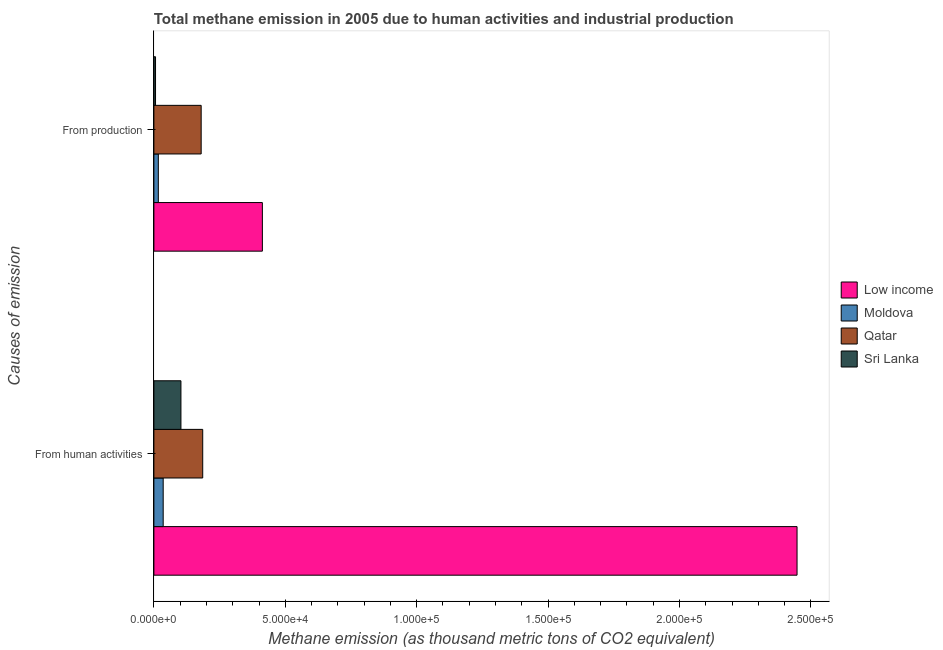Are the number of bars per tick equal to the number of legend labels?
Make the answer very short. Yes. What is the label of the 2nd group of bars from the top?
Your response must be concise. From human activities. What is the amount of emissions generated from industries in Sri Lanka?
Your response must be concise. 627.3. Across all countries, what is the maximum amount of emissions from human activities?
Provide a short and direct response. 2.45e+05. Across all countries, what is the minimum amount of emissions generated from industries?
Offer a terse response. 627.3. In which country was the amount of emissions generated from industries maximum?
Your response must be concise. Low income. In which country was the amount of emissions from human activities minimum?
Provide a succinct answer. Moldova. What is the total amount of emissions from human activities in the graph?
Your response must be concise. 2.77e+05. What is the difference between the amount of emissions from human activities in Qatar and that in Low income?
Your answer should be compact. -2.26e+05. What is the difference between the amount of emissions generated from industries in Sri Lanka and the amount of emissions from human activities in Low income?
Make the answer very short. -2.44e+05. What is the average amount of emissions from human activities per country?
Ensure brevity in your answer.  6.93e+04. What is the difference between the amount of emissions generated from industries and amount of emissions from human activities in Moldova?
Provide a succinct answer. -1849.5. What is the ratio of the amount of emissions generated from industries in Low income to that in Qatar?
Give a very brief answer. 2.29. What does the 3rd bar from the bottom in From human activities represents?
Your answer should be very brief. Qatar. How many bars are there?
Your answer should be compact. 8. Are the values on the major ticks of X-axis written in scientific E-notation?
Make the answer very short. Yes. Does the graph contain any zero values?
Keep it short and to the point. No. Where does the legend appear in the graph?
Give a very brief answer. Center right. What is the title of the graph?
Provide a succinct answer. Total methane emission in 2005 due to human activities and industrial production. Does "United Arab Emirates" appear as one of the legend labels in the graph?
Provide a succinct answer. No. What is the label or title of the X-axis?
Your answer should be very brief. Methane emission (as thousand metric tons of CO2 equivalent). What is the label or title of the Y-axis?
Keep it short and to the point. Causes of emission. What is the Methane emission (as thousand metric tons of CO2 equivalent) of Low income in From human activities?
Your answer should be compact. 2.45e+05. What is the Methane emission (as thousand metric tons of CO2 equivalent) of Moldova in From human activities?
Offer a terse response. 3540.6. What is the Methane emission (as thousand metric tons of CO2 equivalent) in Qatar in From human activities?
Provide a succinct answer. 1.86e+04. What is the Methane emission (as thousand metric tons of CO2 equivalent) of Sri Lanka in From human activities?
Your answer should be compact. 1.03e+04. What is the Methane emission (as thousand metric tons of CO2 equivalent) of Low income in From production?
Provide a short and direct response. 4.13e+04. What is the Methane emission (as thousand metric tons of CO2 equivalent) of Moldova in From production?
Offer a very short reply. 1691.1. What is the Methane emission (as thousand metric tons of CO2 equivalent) in Qatar in From production?
Your answer should be compact. 1.80e+04. What is the Methane emission (as thousand metric tons of CO2 equivalent) of Sri Lanka in From production?
Give a very brief answer. 627.3. Across all Causes of emission, what is the maximum Methane emission (as thousand metric tons of CO2 equivalent) in Low income?
Provide a short and direct response. 2.45e+05. Across all Causes of emission, what is the maximum Methane emission (as thousand metric tons of CO2 equivalent) in Moldova?
Offer a very short reply. 3540.6. Across all Causes of emission, what is the maximum Methane emission (as thousand metric tons of CO2 equivalent) of Qatar?
Offer a terse response. 1.86e+04. Across all Causes of emission, what is the maximum Methane emission (as thousand metric tons of CO2 equivalent) in Sri Lanka?
Offer a very short reply. 1.03e+04. Across all Causes of emission, what is the minimum Methane emission (as thousand metric tons of CO2 equivalent) in Low income?
Offer a terse response. 4.13e+04. Across all Causes of emission, what is the minimum Methane emission (as thousand metric tons of CO2 equivalent) in Moldova?
Keep it short and to the point. 1691.1. Across all Causes of emission, what is the minimum Methane emission (as thousand metric tons of CO2 equivalent) in Qatar?
Make the answer very short. 1.80e+04. Across all Causes of emission, what is the minimum Methane emission (as thousand metric tons of CO2 equivalent) of Sri Lanka?
Offer a terse response. 627.3. What is the total Methane emission (as thousand metric tons of CO2 equivalent) of Low income in the graph?
Keep it short and to the point. 2.86e+05. What is the total Methane emission (as thousand metric tons of CO2 equivalent) of Moldova in the graph?
Your answer should be compact. 5231.7. What is the total Methane emission (as thousand metric tons of CO2 equivalent) in Qatar in the graph?
Provide a succinct answer. 3.66e+04. What is the total Methane emission (as thousand metric tons of CO2 equivalent) in Sri Lanka in the graph?
Your response must be concise. 1.09e+04. What is the difference between the Methane emission (as thousand metric tons of CO2 equivalent) of Low income in From human activities and that in From production?
Give a very brief answer. 2.03e+05. What is the difference between the Methane emission (as thousand metric tons of CO2 equivalent) of Moldova in From human activities and that in From production?
Ensure brevity in your answer.  1849.5. What is the difference between the Methane emission (as thousand metric tons of CO2 equivalent) in Qatar in From human activities and that in From production?
Provide a short and direct response. 589.5. What is the difference between the Methane emission (as thousand metric tons of CO2 equivalent) in Sri Lanka in From human activities and that in From production?
Provide a short and direct response. 9667.2. What is the difference between the Methane emission (as thousand metric tons of CO2 equivalent) in Low income in From human activities and the Methane emission (as thousand metric tons of CO2 equivalent) in Moldova in From production?
Offer a very short reply. 2.43e+05. What is the difference between the Methane emission (as thousand metric tons of CO2 equivalent) in Low income in From human activities and the Methane emission (as thousand metric tons of CO2 equivalent) in Qatar in From production?
Your answer should be very brief. 2.27e+05. What is the difference between the Methane emission (as thousand metric tons of CO2 equivalent) in Low income in From human activities and the Methane emission (as thousand metric tons of CO2 equivalent) in Sri Lanka in From production?
Your answer should be very brief. 2.44e+05. What is the difference between the Methane emission (as thousand metric tons of CO2 equivalent) of Moldova in From human activities and the Methane emission (as thousand metric tons of CO2 equivalent) of Qatar in From production?
Your answer should be compact. -1.45e+04. What is the difference between the Methane emission (as thousand metric tons of CO2 equivalent) of Moldova in From human activities and the Methane emission (as thousand metric tons of CO2 equivalent) of Sri Lanka in From production?
Ensure brevity in your answer.  2913.3. What is the difference between the Methane emission (as thousand metric tons of CO2 equivalent) in Qatar in From human activities and the Methane emission (as thousand metric tons of CO2 equivalent) in Sri Lanka in From production?
Your response must be concise. 1.80e+04. What is the average Methane emission (as thousand metric tons of CO2 equivalent) in Low income per Causes of emission?
Offer a terse response. 1.43e+05. What is the average Methane emission (as thousand metric tons of CO2 equivalent) in Moldova per Causes of emission?
Ensure brevity in your answer.  2615.85. What is the average Methane emission (as thousand metric tons of CO2 equivalent) in Qatar per Causes of emission?
Your answer should be very brief. 1.83e+04. What is the average Methane emission (as thousand metric tons of CO2 equivalent) in Sri Lanka per Causes of emission?
Your answer should be very brief. 5460.9. What is the difference between the Methane emission (as thousand metric tons of CO2 equivalent) of Low income and Methane emission (as thousand metric tons of CO2 equivalent) of Moldova in From human activities?
Your response must be concise. 2.41e+05. What is the difference between the Methane emission (as thousand metric tons of CO2 equivalent) of Low income and Methane emission (as thousand metric tons of CO2 equivalent) of Qatar in From human activities?
Provide a short and direct response. 2.26e+05. What is the difference between the Methane emission (as thousand metric tons of CO2 equivalent) in Low income and Methane emission (as thousand metric tons of CO2 equivalent) in Sri Lanka in From human activities?
Your answer should be compact. 2.34e+05. What is the difference between the Methane emission (as thousand metric tons of CO2 equivalent) of Moldova and Methane emission (as thousand metric tons of CO2 equivalent) of Qatar in From human activities?
Give a very brief answer. -1.50e+04. What is the difference between the Methane emission (as thousand metric tons of CO2 equivalent) of Moldova and Methane emission (as thousand metric tons of CO2 equivalent) of Sri Lanka in From human activities?
Your response must be concise. -6753.9. What is the difference between the Methane emission (as thousand metric tons of CO2 equivalent) of Qatar and Methane emission (as thousand metric tons of CO2 equivalent) of Sri Lanka in From human activities?
Provide a short and direct response. 8286.2. What is the difference between the Methane emission (as thousand metric tons of CO2 equivalent) in Low income and Methane emission (as thousand metric tons of CO2 equivalent) in Moldova in From production?
Make the answer very short. 3.96e+04. What is the difference between the Methane emission (as thousand metric tons of CO2 equivalent) in Low income and Methane emission (as thousand metric tons of CO2 equivalent) in Qatar in From production?
Your answer should be compact. 2.33e+04. What is the difference between the Methane emission (as thousand metric tons of CO2 equivalent) of Low income and Methane emission (as thousand metric tons of CO2 equivalent) of Sri Lanka in From production?
Offer a very short reply. 4.07e+04. What is the difference between the Methane emission (as thousand metric tons of CO2 equivalent) of Moldova and Methane emission (as thousand metric tons of CO2 equivalent) of Qatar in From production?
Your answer should be very brief. -1.63e+04. What is the difference between the Methane emission (as thousand metric tons of CO2 equivalent) in Moldova and Methane emission (as thousand metric tons of CO2 equivalent) in Sri Lanka in From production?
Provide a succinct answer. 1063.8. What is the difference between the Methane emission (as thousand metric tons of CO2 equivalent) in Qatar and Methane emission (as thousand metric tons of CO2 equivalent) in Sri Lanka in From production?
Your response must be concise. 1.74e+04. What is the ratio of the Methane emission (as thousand metric tons of CO2 equivalent) of Low income in From human activities to that in From production?
Offer a terse response. 5.93. What is the ratio of the Methane emission (as thousand metric tons of CO2 equivalent) in Moldova in From human activities to that in From production?
Ensure brevity in your answer.  2.09. What is the ratio of the Methane emission (as thousand metric tons of CO2 equivalent) in Qatar in From human activities to that in From production?
Your response must be concise. 1.03. What is the ratio of the Methane emission (as thousand metric tons of CO2 equivalent) in Sri Lanka in From human activities to that in From production?
Make the answer very short. 16.41. What is the difference between the highest and the second highest Methane emission (as thousand metric tons of CO2 equivalent) of Low income?
Provide a succinct answer. 2.03e+05. What is the difference between the highest and the second highest Methane emission (as thousand metric tons of CO2 equivalent) of Moldova?
Give a very brief answer. 1849.5. What is the difference between the highest and the second highest Methane emission (as thousand metric tons of CO2 equivalent) of Qatar?
Your response must be concise. 589.5. What is the difference between the highest and the second highest Methane emission (as thousand metric tons of CO2 equivalent) in Sri Lanka?
Your answer should be very brief. 9667.2. What is the difference between the highest and the lowest Methane emission (as thousand metric tons of CO2 equivalent) in Low income?
Your response must be concise. 2.03e+05. What is the difference between the highest and the lowest Methane emission (as thousand metric tons of CO2 equivalent) in Moldova?
Your response must be concise. 1849.5. What is the difference between the highest and the lowest Methane emission (as thousand metric tons of CO2 equivalent) of Qatar?
Ensure brevity in your answer.  589.5. What is the difference between the highest and the lowest Methane emission (as thousand metric tons of CO2 equivalent) in Sri Lanka?
Keep it short and to the point. 9667.2. 